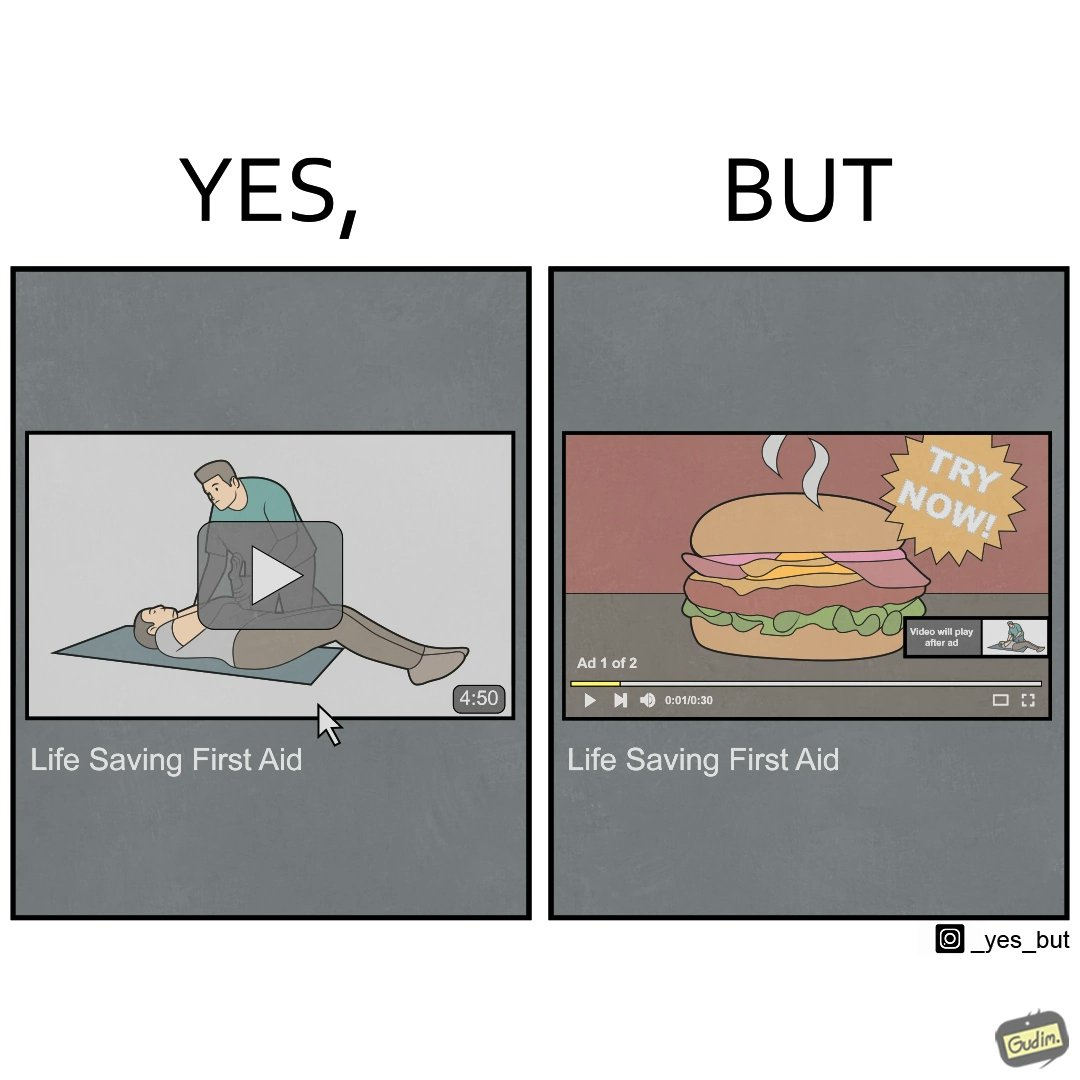What makes this image funny or satirical? The image is ironical, as when watching a video of 4 mins 50 secs on "Life Saving First Aid", you have to see two ads, the first of which is a lengthy ad of 30 secs, and is a Burger Commercial, which is harmful for health and life, contradictory to the original video. 